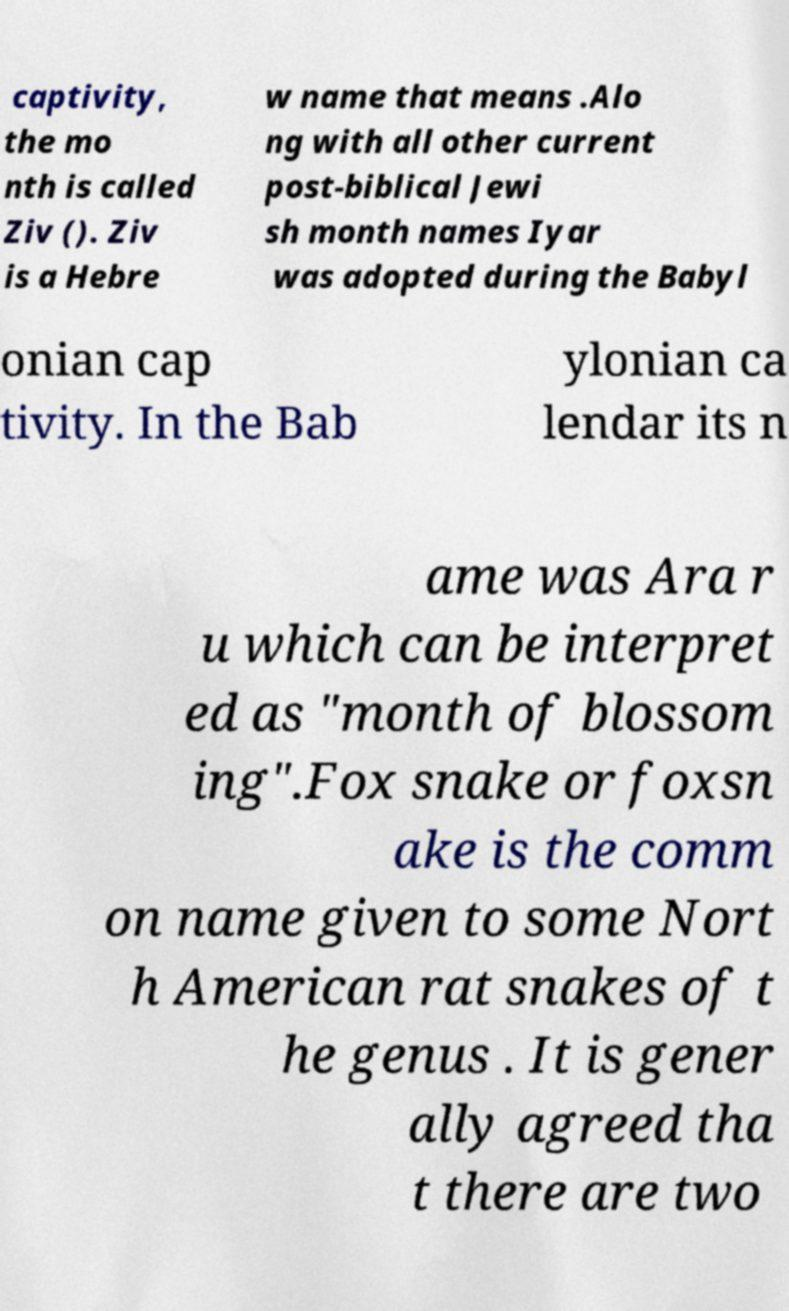Could you extract and type out the text from this image? captivity, the mo nth is called Ziv (). Ziv is a Hebre w name that means .Alo ng with all other current post-biblical Jewi sh month names Iyar was adopted during the Babyl onian cap tivity. In the Bab ylonian ca lendar its n ame was Ara r u which can be interpret ed as "month of blossom ing".Fox snake or foxsn ake is the comm on name given to some Nort h American rat snakes of t he genus . It is gener ally agreed tha t there are two 